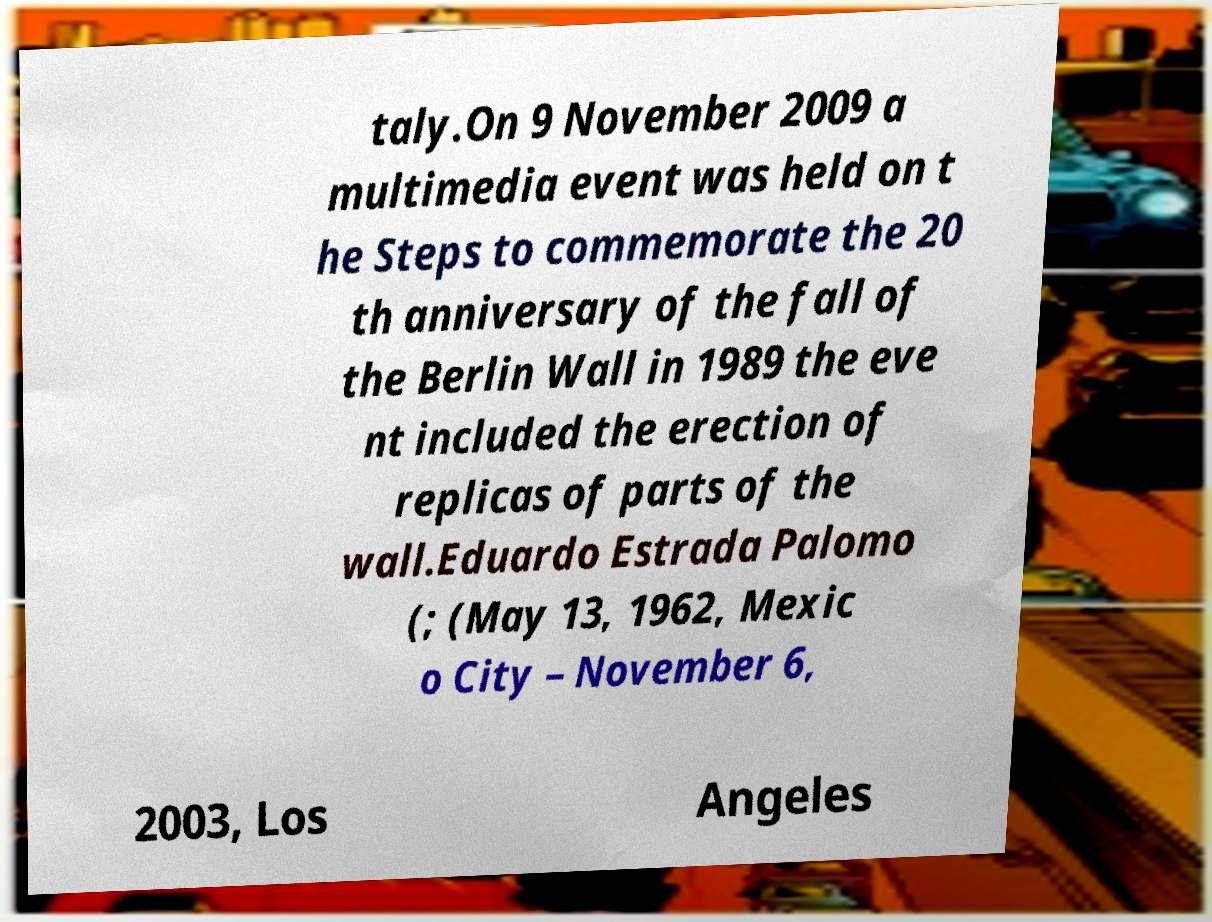Could you assist in decoding the text presented in this image and type it out clearly? taly.On 9 November 2009 a multimedia event was held on t he Steps to commemorate the 20 th anniversary of the fall of the Berlin Wall in 1989 the eve nt included the erection of replicas of parts of the wall.Eduardo Estrada Palomo (; (May 13, 1962, Mexic o City – November 6, 2003, Los Angeles 